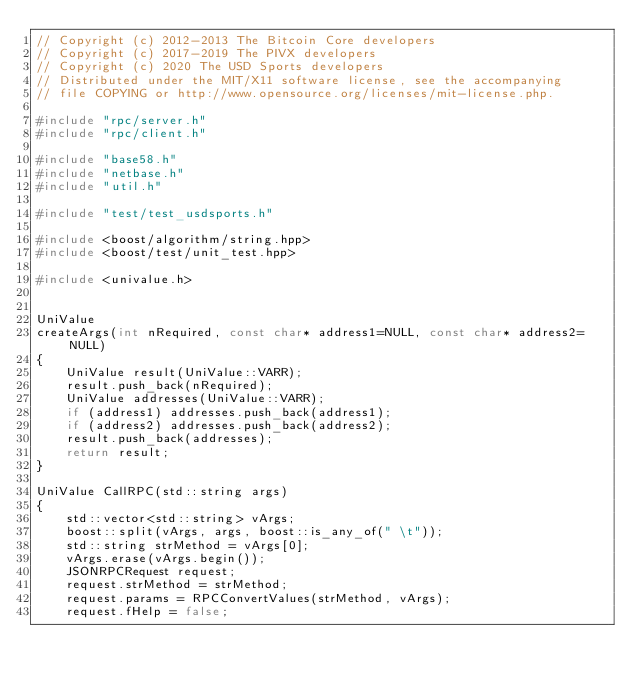Convert code to text. <code><loc_0><loc_0><loc_500><loc_500><_C++_>// Copyright (c) 2012-2013 The Bitcoin Core developers
// Copyright (c) 2017-2019 The PIVX developers
// Copyright (c) 2020 The USD Sports developers
// Distributed under the MIT/X11 software license, see the accompanying
// file COPYING or http://www.opensource.org/licenses/mit-license.php.

#include "rpc/server.h"
#include "rpc/client.h"

#include "base58.h"
#include "netbase.h"
#include "util.h"

#include "test/test_usdsports.h"

#include <boost/algorithm/string.hpp>
#include <boost/test/unit_test.hpp>

#include <univalue.h>


UniValue
createArgs(int nRequired, const char* address1=NULL, const char* address2=NULL)
{
    UniValue result(UniValue::VARR);
    result.push_back(nRequired);
    UniValue addresses(UniValue::VARR);
    if (address1) addresses.push_back(address1);
    if (address2) addresses.push_back(address2);
    result.push_back(addresses);
    return result;
}

UniValue CallRPC(std::string args)
{
    std::vector<std::string> vArgs;
    boost::split(vArgs, args, boost::is_any_of(" \t"));
    std::string strMethod = vArgs[0];
    vArgs.erase(vArgs.begin());
    JSONRPCRequest request;
    request.strMethod = strMethod;
    request.params = RPCConvertValues(strMethod, vArgs);
    request.fHelp = false;</code> 